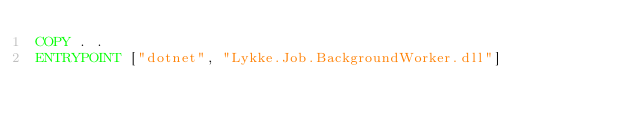Convert code to text. <code><loc_0><loc_0><loc_500><loc_500><_Dockerfile_>COPY . .
ENTRYPOINT ["dotnet", "Lykke.Job.BackgroundWorker.dll"]
</code> 